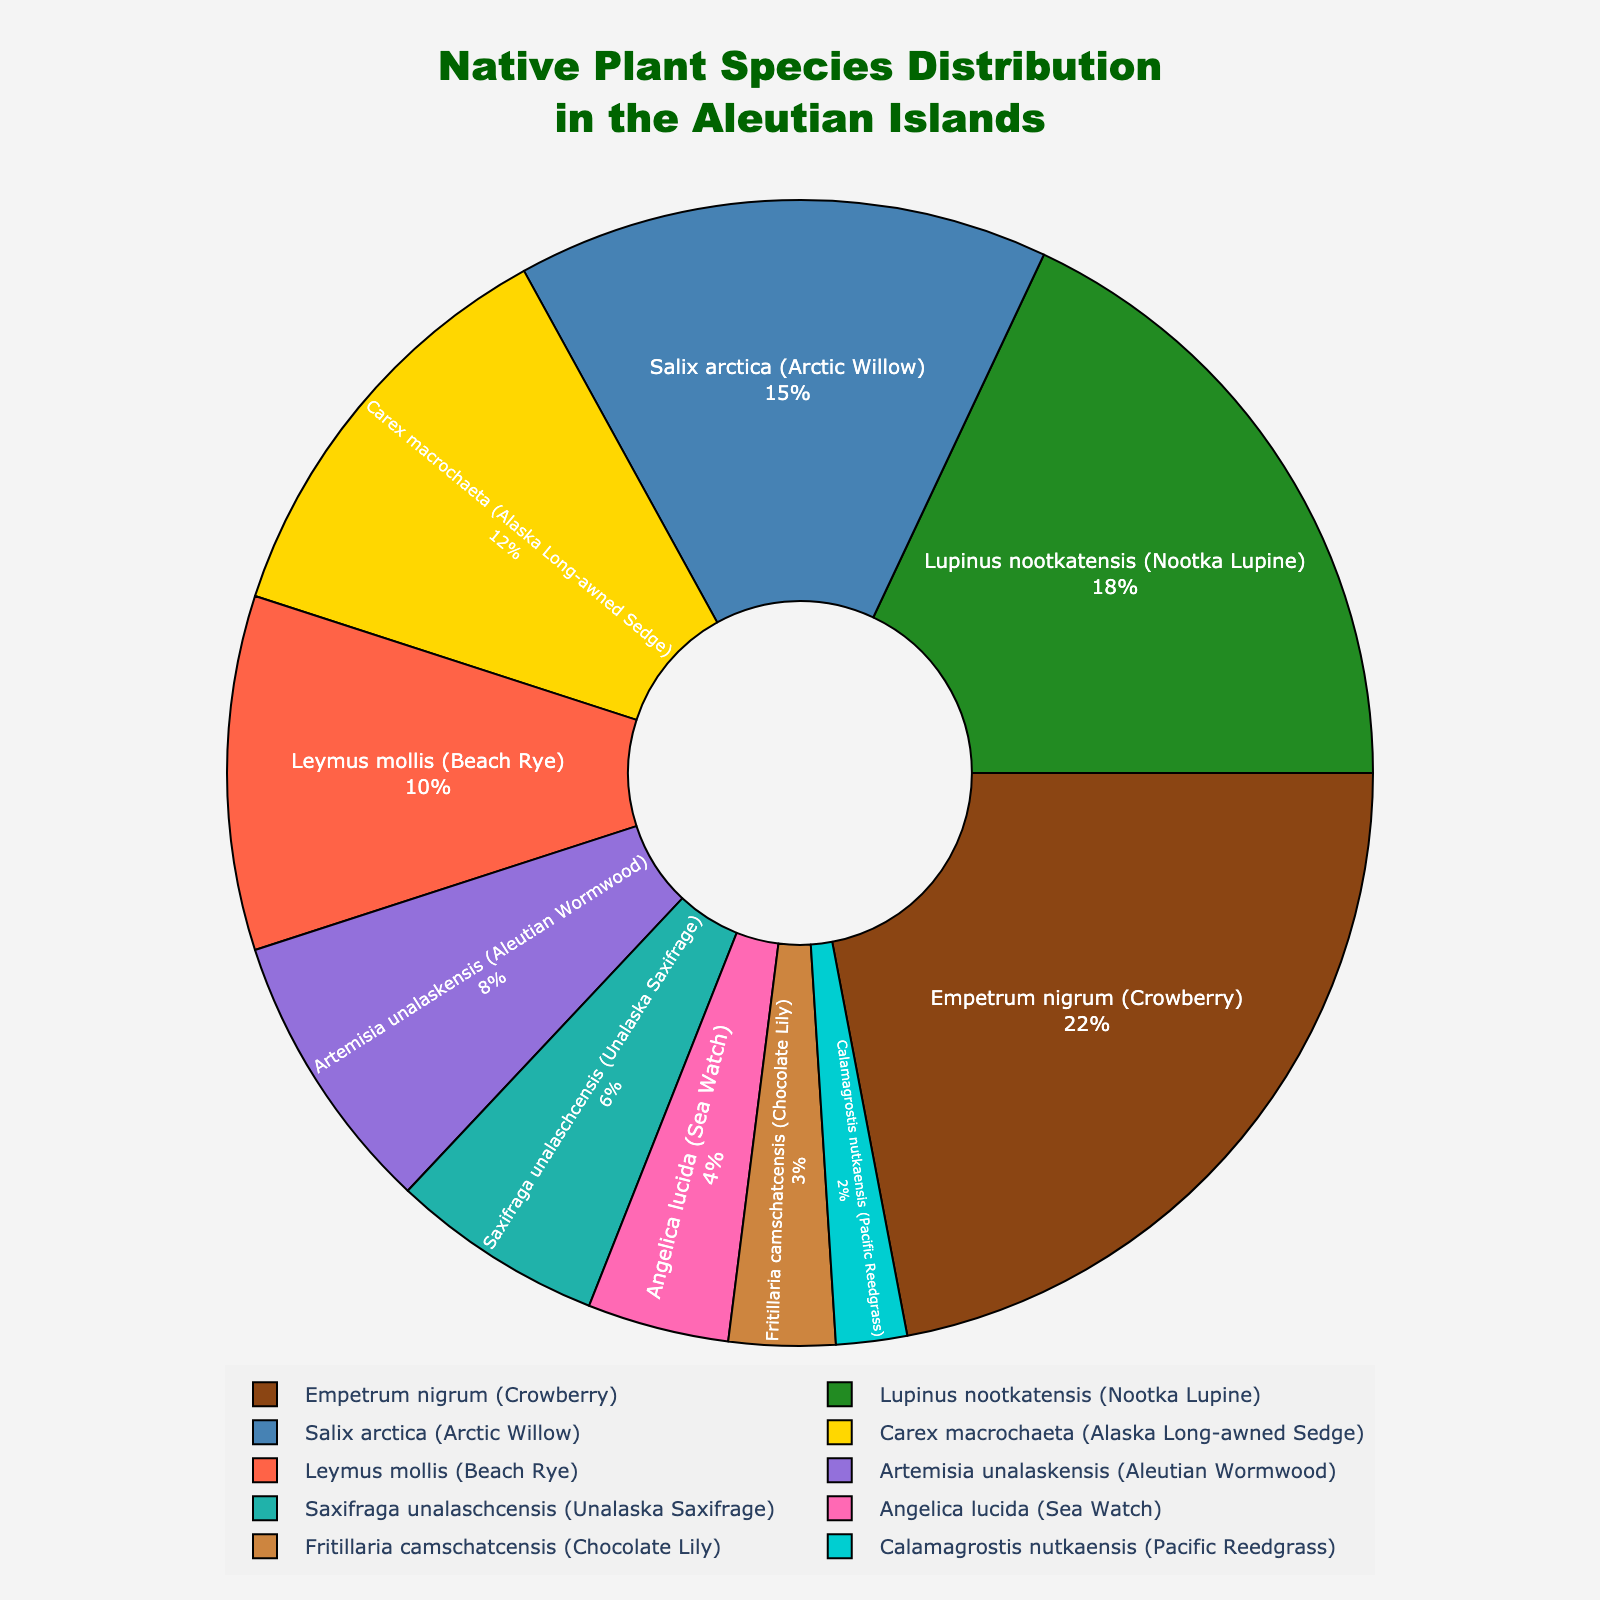Which plant species is the most abundant? The most abundant species is the one with the highest percentage in the pie chart. Crowberry (Empetrum nigrum) has the highest percentage.
Answer: Empetrum nigrum (Crowberry) Which plant species has the smallest percentage? The species with the smallest percentage is the one represented by the smallest slice in the pie chart. Pacific Reedgrass (Calamagrostis nutkaensis) has the smallest percentage.
Answer: Calamagrostis nutkaensis (Pacific Reedgrass) What's the combined percentage of Nootka Lupine (Lupinus nootkatensis) and Arctic Willow (Salix arctica)? Add the percentages of Nootka Lupine and Arctic Willow: 18% + 15% = 33%.
Answer: 33% Which plant species have percentages greater than 10%? The species with percentages greater than 10% are found by identifying all slices larger than 10% in the pie chart. They are Crowberry, Nootka Lupine, Arctic Willow, and Alaska Long-awned Sedge.
Answer: Empetrum nigrum, Lupinus nootkatensis, Salix arctica, Carex macrochaeta How much less is the percentage of Aleutian Wormwood (Artemisia unalaskensis) compared to Beach Rye (Leymus mollis)? Subtract the percentage of Aleutian Wormwood from that of Beach Rye: 10% - 8% = 2%.
Answer: 2% What's the average percentage of the three least abundant species? Identify the three least abundant species and calculate their average: (3% + 2% + 4%) / 3 = 9% / 3 = 3%.
Answer: 3% What is the color of the species that has an 8% share in the chart? The species with an 8% share is Aleutian Wormwood (Artemisia unalaskensis), and it's often represented by the color pink in this chart.
Answer: Pink Rank the top three plant species in descending order of their percentage. Identify the species with the highest percentages and rank them: Crowberry (22%), Nootka Lupine (18%), and Arctic Willow (15%).
Answer: Empetrum nigrum, Lupinus nootkatensis, Salix arctica If you combine the percentages of Alaska Long-awned Sedge (Carex macrochaeta) and Beach Rye (Leymus mollis), will it be greater or less than the percentage of Crowberry (Empetrum nigrum)? Add the percentages of Alaska Long-awned Sedge and Beach Rye: 12% + 10% = 22%. Since Crowberry is also 22%, it's equal.
Answer: Equal 